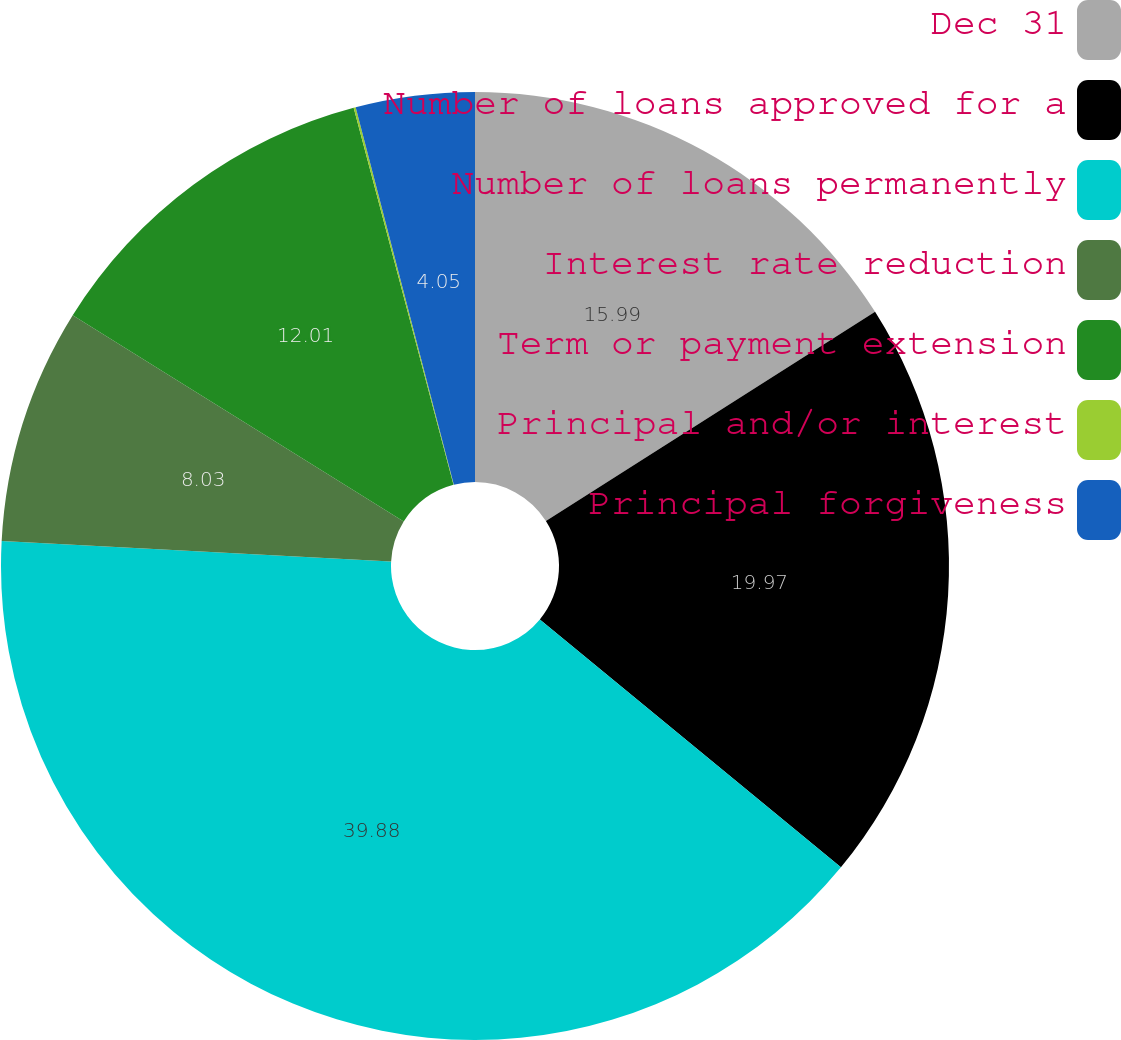Convert chart. <chart><loc_0><loc_0><loc_500><loc_500><pie_chart><fcel>Dec 31<fcel>Number of loans approved for a<fcel>Number of loans permanently<fcel>Interest rate reduction<fcel>Term or payment extension<fcel>Principal and/or interest<fcel>Principal forgiveness<nl><fcel>15.99%<fcel>19.97%<fcel>39.87%<fcel>8.03%<fcel>12.01%<fcel>0.07%<fcel>4.05%<nl></chart> 